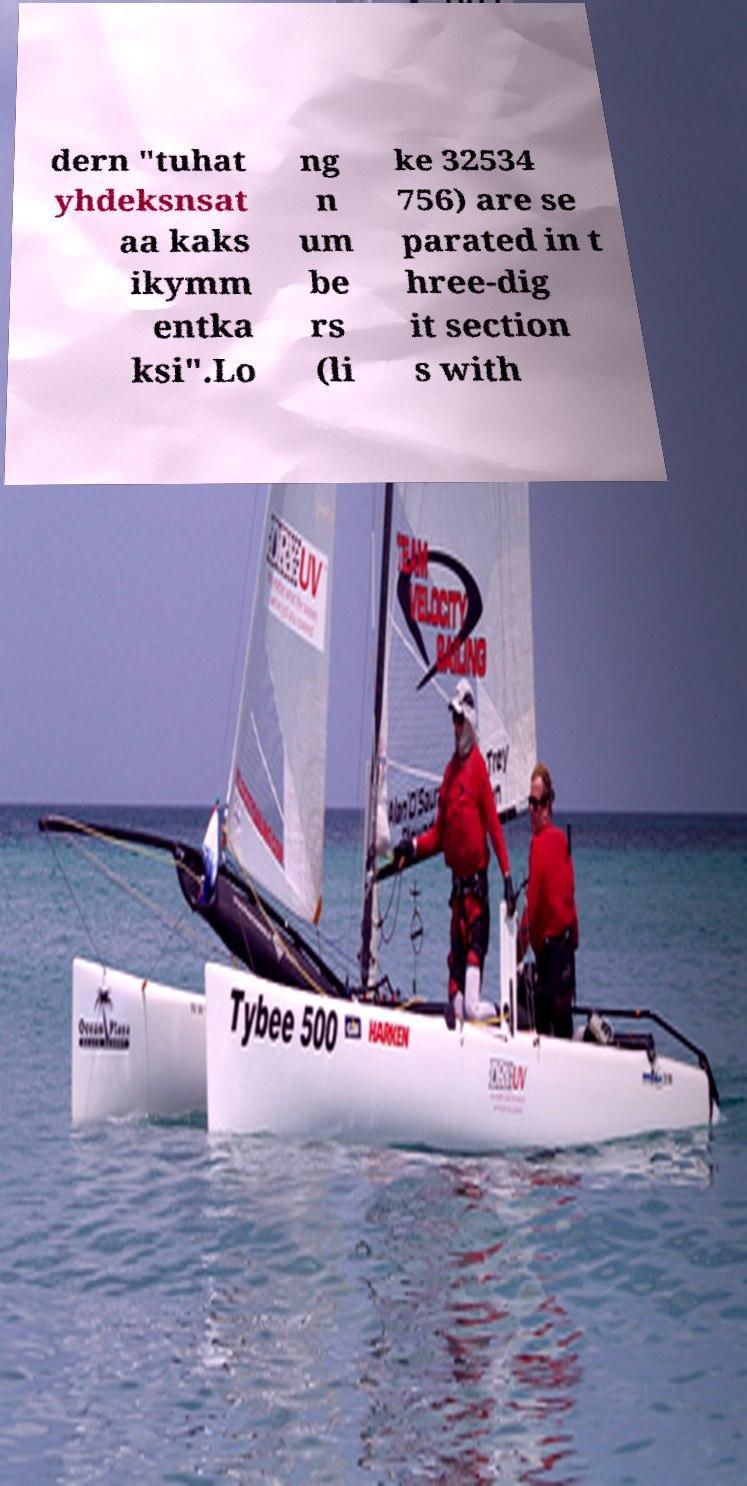Please identify and transcribe the text found in this image. dern "tuhat yhdeksnsat aa kaks ikymm entka ksi".Lo ng n um be rs (li ke 32534 756) are se parated in t hree-dig it section s with 